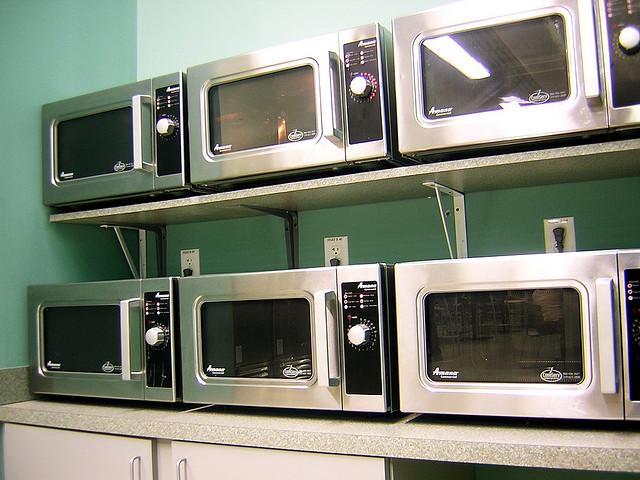Do you think this would be a busy place at lunchtime?
Short answer required. Yes. What type of appliance is this?
Be succinct. Microwave. Are the appliances plugged in?
Answer briefly. Yes. 